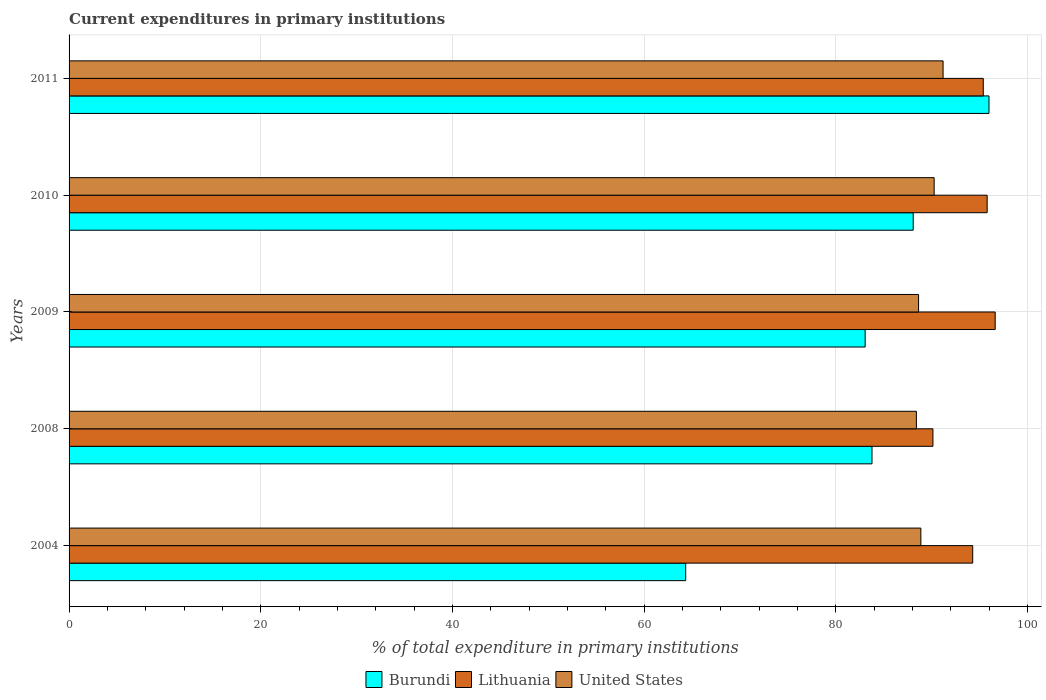How many different coloured bars are there?
Give a very brief answer. 3. How many groups of bars are there?
Your response must be concise. 5. How many bars are there on the 1st tick from the top?
Offer a very short reply. 3. How many bars are there on the 4th tick from the bottom?
Give a very brief answer. 3. In how many cases, is the number of bars for a given year not equal to the number of legend labels?
Offer a terse response. 0. What is the current expenditures in primary institutions in United States in 2010?
Give a very brief answer. 90.27. Across all years, what is the maximum current expenditures in primary institutions in Lithuania?
Your answer should be very brief. 96.64. Across all years, what is the minimum current expenditures in primary institutions in United States?
Give a very brief answer. 88.42. In which year was the current expenditures in primary institutions in Burundi maximum?
Your answer should be compact. 2011. What is the total current expenditures in primary institutions in United States in the graph?
Keep it short and to the point. 447.44. What is the difference between the current expenditures in primary institutions in Lithuania in 2009 and that in 2011?
Keep it short and to the point. 1.24. What is the difference between the current expenditures in primary institutions in United States in 2011 and the current expenditures in primary institutions in Burundi in 2008?
Offer a terse response. 7.42. What is the average current expenditures in primary institutions in Burundi per year?
Offer a terse response. 83.06. In the year 2008, what is the difference between the current expenditures in primary institutions in United States and current expenditures in primary institutions in Lithuania?
Your response must be concise. -1.73. In how many years, is the current expenditures in primary institutions in Burundi greater than 32 %?
Ensure brevity in your answer.  5. What is the ratio of the current expenditures in primary institutions in Lithuania in 2004 to that in 2009?
Provide a succinct answer. 0.98. What is the difference between the highest and the second highest current expenditures in primary institutions in Burundi?
Provide a short and direct response. 7.91. What is the difference between the highest and the lowest current expenditures in primary institutions in Burundi?
Offer a terse response. 31.65. What does the 2nd bar from the top in 2004 represents?
Provide a succinct answer. Lithuania. What does the 3rd bar from the bottom in 2004 represents?
Offer a very short reply. United States. Is it the case that in every year, the sum of the current expenditures in primary institutions in Burundi and current expenditures in primary institutions in Lithuania is greater than the current expenditures in primary institutions in United States?
Ensure brevity in your answer.  Yes. How many bars are there?
Provide a succinct answer. 15. Are all the bars in the graph horizontal?
Ensure brevity in your answer.  Yes. How many years are there in the graph?
Offer a terse response. 5. Does the graph contain grids?
Give a very brief answer. Yes. What is the title of the graph?
Provide a succinct answer. Current expenditures in primary institutions. What is the label or title of the X-axis?
Provide a succinct answer. % of total expenditure in primary institutions. What is the % of total expenditure in primary institutions of Burundi in 2004?
Your answer should be very brief. 64.35. What is the % of total expenditure in primary institutions of Lithuania in 2004?
Your response must be concise. 94.3. What is the % of total expenditure in primary institutions in United States in 2004?
Make the answer very short. 88.89. What is the % of total expenditure in primary institutions in Burundi in 2008?
Your answer should be compact. 83.79. What is the % of total expenditure in primary institutions in Lithuania in 2008?
Offer a terse response. 90.15. What is the % of total expenditure in primary institutions of United States in 2008?
Provide a succinct answer. 88.42. What is the % of total expenditure in primary institutions of Burundi in 2009?
Provide a short and direct response. 83.07. What is the % of total expenditure in primary institutions of Lithuania in 2009?
Make the answer very short. 96.64. What is the % of total expenditure in primary institutions in United States in 2009?
Make the answer very short. 88.65. What is the % of total expenditure in primary institutions in Burundi in 2010?
Provide a short and direct response. 88.09. What is the % of total expenditure in primary institutions of Lithuania in 2010?
Provide a short and direct response. 95.81. What is the % of total expenditure in primary institutions of United States in 2010?
Provide a short and direct response. 90.27. What is the % of total expenditure in primary institutions in Burundi in 2011?
Give a very brief answer. 96. What is the % of total expenditure in primary institutions in Lithuania in 2011?
Give a very brief answer. 95.4. What is the % of total expenditure in primary institutions in United States in 2011?
Offer a very short reply. 91.21. Across all years, what is the maximum % of total expenditure in primary institutions in Burundi?
Offer a terse response. 96. Across all years, what is the maximum % of total expenditure in primary institutions in Lithuania?
Make the answer very short. 96.64. Across all years, what is the maximum % of total expenditure in primary institutions in United States?
Offer a terse response. 91.21. Across all years, what is the minimum % of total expenditure in primary institutions of Burundi?
Ensure brevity in your answer.  64.35. Across all years, what is the minimum % of total expenditure in primary institutions in Lithuania?
Make the answer very short. 90.15. Across all years, what is the minimum % of total expenditure in primary institutions in United States?
Offer a very short reply. 88.42. What is the total % of total expenditure in primary institutions in Burundi in the graph?
Make the answer very short. 415.29. What is the total % of total expenditure in primary institutions of Lithuania in the graph?
Your answer should be compact. 472.29. What is the total % of total expenditure in primary institutions in United States in the graph?
Your answer should be compact. 447.44. What is the difference between the % of total expenditure in primary institutions of Burundi in 2004 and that in 2008?
Your response must be concise. -19.44. What is the difference between the % of total expenditure in primary institutions in Lithuania in 2004 and that in 2008?
Your answer should be compact. 4.15. What is the difference between the % of total expenditure in primary institutions of United States in 2004 and that in 2008?
Make the answer very short. 0.47. What is the difference between the % of total expenditure in primary institutions in Burundi in 2004 and that in 2009?
Your answer should be compact. -18.73. What is the difference between the % of total expenditure in primary institutions in Lithuania in 2004 and that in 2009?
Make the answer very short. -2.35. What is the difference between the % of total expenditure in primary institutions of United States in 2004 and that in 2009?
Offer a terse response. 0.24. What is the difference between the % of total expenditure in primary institutions in Burundi in 2004 and that in 2010?
Give a very brief answer. -23.74. What is the difference between the % of total expenditure in primary institutions in Lithuania in 2004 and that in 2010?
Your answer should be compact. -1.51. What is the difference between the % of total expenditure in primary institutions of United States in 2004 and that in 2010?
Your answer should be compact. -1.39. What is the difference between the % of total expenditure in primary institutions in Burundi in 2004 and that in 2011?
Your answer should be very brief. -31.65. What is the difference between the % of total expenditure in primary institutions of Lithuania in 2004 and that in 2011?
Give a very brief answer. -1.1. What is the difference between the % of total expenditure in primary institutions of United States in 2004 and that in 2011?
Offer a very short reply. -2.32. What is the difference between the % of total expenditure in primary institutions of Burundi in 2008 and that in 2009?
Make the answer very short. 0.71. What is the difference between the % of total expenditure in primary institutions of Lithuania in 2008 and that in 2009?
Keep it short and to the point. -6.5. What is the difference between the % of total expenditure in primary institutions of United States in 2008 and that in 2009?
Make the answer very short. -0.23. What is the difference between the % of total expenditure in primary institutions of Burundi in 2008 and that in 2010?
Provide a succinct answer. -4.3. What is the difference between the % of total expenditure in primary institutions of Lithuania in 2008 and that in 2010?
Your response must be concise. -5.66. What is the difference between the % of total expenditure in primary institutions in United States in 2008 and that in 2010?
Offer a very short reply. -1.85. What is the difference between the % of total expenditure in primary institutions of Burundi in 2008 and that in 2011?
Offer a very short reply. -12.21. What is the difference between the % of total expenditure in primary institutions of Lithuania in 2008 and that in 2011?
Provide a succinct answer. -5.25. What is the difference between the % of total expenditure in primary institutions in United States in 2008 and that in 2011?
Offer a very short reply. -2.78. What is the difference between the % of total expenditure in primary institutions in Burundi in 2009 and that in 2010?
Give a very brief answer. -5.01. What is the difference between the % of total expenditure in primary institutions of Lithuania in 2009 and that in 2010?
Keep it short and to the point. 0.84. What is the difference between the % of total expenditure in primary institutions in United States in 2009 and that in 2010?
Your response must be concise. -1.63. What is the difference between the % of total expenditure in primary institutions of Burundi in 2009 and that in 2011?
Ensure brevity in your answer.  -12.92. What is the difference between the % of total expenditure in primary institutions in Lithuania in 2009 and that in 2011?
Provide a succinct answer. 1.24. What is the difference between the % of total expenditure in primary institutions of United States in 2009 and that in 2011?
Offer a terse response. -2.56. What is the difference between the % of total expenditure in primary institutions in Burundi in 2010 and that in 2011?
Keep it short and to the point. -7.91. What is the difference between the % of total expenditure in primary institutions of Lithuania in 2010 and that in 2011?
Make the answer very short. 0.4. What is the difference between the % of total expenditure in primary institutions in United States in 2010 and that in 2011?
Ensure brevity in your answer.  -0.93. What is the difference between the % of total expenditure in primary institutions of Burundi in 2004 and the % of total expenditure in primary institutions of Lithuania in 2008?
Provide a short and direct response. -25.8. What is the difference between the % of total expenditure in primary institutions of Burundi in 2004 and the % of total expenditure in primary institutions of United States in 2008?
Offer a terse response. -24.07. What is the difference between the % of total expenditure in primary institutions of Lithuania in 2004 and the % of total expenditure in primary institutions of United States in 2008?
Your answer should be compact. 5.88. What is the difference between the % of total expenditure in primary institutions in Burundi in 2004 and the % of total expenditure in primary institutions in Lithuania in 2009?
Make the answer very short. -32.3. What is the difference between the % of total expenditure in primary institutions of Burundi in 2004 and the % of total expenditure in primary institutions of United States in 2009?
Your answer should be compact. -24.3. What is the difference between the % of total expenditure in primary institutions of Lithuania in 2004 and the % of total expenditure in primary institutions of United States in 2009?
Your answer should be very brief. 5.65. What is the difference between the % of total expenditure in primary institutions of Burundi in 2004 and the % of total expenditure in primary institutions of Lithuania in 2010?
Keep it short and to the point. -31.46. What is the difference between the % of total expenditure in primary institutions in Burundi in 2004 and the % of total expenditure in primary institutions in United States in 2010?
Ensure brevity in your answer.  -25.93. What is the difference between the % of total expenditure in primary institutions in Lithuania in 2004 and the % of total expenditure in primary institutions in United States in 2010?
Your answer should be very brief. 4.02. What is the difference between the % of total expenditure in primary institutions in Burundi in 2004 and the % of total expenditure in primary institutions in Lithuania in 2011?
Your answer should be compact. -31.05. What is the difference between the % of total expenditure in primary institutions in Burundi in 2004 and the % of total expenditure in primary institutions in United States in 2011?
Provide a succinct answer. -26.86. What is the difference between the % of total expenditure in primary institutions of Lithuania in 2004 and the % of total expenditure in primary institutions of United States in 2011?
Offer a terse response. 3.09. What is the difference between the % of total expenditure in primary institutions in Burundi in 2008 and the % of total expenditure in primary institutions in Lithuania in 2009?
Your answer should be compact. -12.85. What is the difference between the % of total expenditure in primary institutions in Burundi in 2008 and the % of total expenditure in primary institutions in United States in 2009?
Give a very brief answer. -4.86. What is the difference between the % of total expenditure in primary institutions in Lithuania in 2008 and the % of total expenditure in primary institutions in United States in 2009?
Your answer should be compact. 1.5. What is the difference between the % of total expenditure in primary institutions of Burundi in 2008 and the % of total expenditure in primary institutions of Lithuania in 2010?
Give a very brief answer. -12.02. What is the difference between the % of total expenditure in primary institutions of Burundi in 2008 and the % of total expenditure in primary institutions of United States in 2010?
Offer a terse response. -6.49. What is the difference between the % of total expenditure in primary institutions in Lithuania in 2008 and the % of total expenditure in primary institutions in United States in 2010?
Ensure brevity in your answer.  -0.13. What is the difference between the % of total expenditure in primary institutions of Burundi in 2008 and the % of total expenditure in primary institutions of Lithuania in 2011?
Provide a short and direct response. -11.61. What is the difference between the % of total expenditure in primary institutions in Burundi in 2008 and the % of total expenditure in primary institutions in United States in 2011?
Offer a very short reply. -7.42. What is the difference between the % of total expenditure in primary institutions of Lithuania in 2008 and the % of total expenditure in primary institutions of United States in 2011?
Offer a terse response. -1.06. What is the difference between the % of total expenditure in primary institutions of Burundi in 2009 and the % of total expenditure in primary institutions of Lithuania in 2010?
Keep it short and to the point. -12.73. What is the difference between the % of total expenditure in primary institutions of Burundi in 2009 and the % of total expenditure in primary institutions of United States in 2010?
Your answer should be very brief. -7.2. What is the difference between the % of total expenditure in primary institutions of Lithuania in 2009 and the % of total expenditure in primary institutions of United States in 2010?
Your answer should be compact. 6.37. What is the difference between the % of total expenditure in primary institutions of Burundi in 2009 and the % of total expenditure in primary institutions of Lithuania in 2011?
Your answer should be very brief. -12.33. What is the difference between the % of total expenditure in primary institutions of Burundi in 2009 and the % of total expenditure in primary institutions of United States in 2011?
Offer a terse response. -8.13. What is the difference between the % of total expenditure in primary institutions of Lithuania in 2009 and the % of total expenditure in primary institutions of United States in 2011?
Provide a short and direct response. 5.44. What is the difference between the % of total expenditure in primary institutions of Burundi in 2010 and the % of total expenditure in primary institutions of Lithuania in 2011?
Ensure brevity in your answer.  -7.31. What is the difference between the % of total expenditure in primary institutions of Burundi in 2010 and the % of total expenditure in primary institutions of United States in 2011?
Offer a very short reply. -3.12. What is the difference between the % of total expenditure in primary institutions in Lithuania in 2010 and the % of total expenditure in primary institutions in United States in 2011?
Provide a short and direct response. 4.6. What is the average % of total expenditure in primary institutions in Burundi per year?
Your answer should be compact. 83.06. What is the average % of total expenditure in primary institutions of Lithuania per year?
Your answer should be compact. 94.46. What is the average % of total expenditure in primary institutions of United States per year?
Offer a very short reply. 89.49. In the year 2004, what is the difference between the % of total expenditure in primary institutions of Burundi and % of total expenditure in primary institutions of Lithuania?
Provide a short and direct response. -29.95. In the year 2004, what is the difference between the % of total expenditure in primary institutions in Burundi and % of total expenditure in primary institutions in United States?
Give a very brief answer. -24.54. In the year 2004, what is the difference between the % of total expenditure in primary institutions in Lithuania and % of total expenditure in primary institutions in United States?
Keep it short and to the point. 5.41. In the year 2008, what is the difference between the % of total expenditure in primary institutions in Burundi and % of total expenditure in primary institutions in Lithuania?
Provide a short and direct response. -6.36. In the year 2008, what is the difference between the % of total expenditure in primary institutions in Burundi and % of total expenditure in primary institutions in United States?
Offer a very short reply. -4.63. In the year 2008, what is the difference between the % of total expenditure in primary institutions of Lithuania and % of total expenditure in primary institutions of United States?
Offer a very short reply. 1.73. In the year 2009, what is the difference between the % of total expenditure in primary institutions of Burundi and % of total expenditure in primary institutions of Lithuania?
Give a very brief answer. -13.57. In the year 2009, what is the difference between the % of total expenditure in primary institutions of Burundi and % of total expenditure in primary institutions of United States?
Provide a succinct answer. -5.57. In the year 2009, what is the difference between the % of total expenditure in primary institutions in Lithuania and % of total expenditure in primary institutions in United States?
Your answer should be very brief. 7.99. In the year 2010, what is the difference between the % of total expenditure in primary institutions of Burundi and % of total expenditure in primary institutions of Lithuania?
Keep it short and to the point. -7.72. In the year 2010, what is the difference between the % of total expenditure in primary institutions in Burundi and % of total expenditure in primary institutions in United States?
Provide a short and direct response. -2.19. In the year 2010, what is the difference between the % of total expenditure in primary institutions in Lithuania and % of total expenditure in primary institutions in United States?
Keep it short and to the point. 5.53. In the year 2011, what is the difference between the % of total expenditure in primary institutions of Burundi and % of total expenditure in primary institutions of Lithuania?
Your answer should be compact. 0.59. In the year 2011, what is the difference between the % of total expenditure in primary institutions in Burundi and % of total expenditure in primary institutions in United States?
Offer a very short reply. 4.79. In the year 2011, what is the difference between the % of total expenditure in primary institutions of Lithuania and % of total expenditure in primary institutions of United States?
Provide a succinct answer. 4.2. What is the ratio of the % of total expenditure in primary institutions of Burundi in 2004 to that in 2008?
Provide a succinct answer. 0.77. What is the ratio of the % of total expenditure in primary institutions in Lithuania in 2004 to that in 2008?
Make the answer very short. 1.05. What is the ratio of the % of total expenditure in primary institutions in Burundi in 2004 to that in 2009?
Keep it short and to the point. 0.77. What is the ratio of the % of total expenditure in primary institutions in Lithuania in 2004 to that in 2009?
Offer a terse response. 0.98. What is the ratio of the % of total expenditure in primary institutions of United States in 2004 to that in 2009?
Your answer should be very brief. 1. What is the ratio of the % of total expenditure in primary institutions of Burundi in 2004 to that in 2010?
Your response must be concise. 0.73. What is the ratio of the % of total expenditure in primary institutions of Lithuania in 2004 to that in 2010?
Offer a very short reply. 0.98. What is the ratio of the % of total expenditure in primary institutions in United States in 2004 to that in 2010?
Offer a terse response. 0.98. What is the ratio of the % of total expenditure in primary institutions of Burundi in 2004 to that in 2011?
Make the answer very short. 0.67. What is the ratio of the % of total expenditure in primary institutions in Lithuania in 2004 to that in 2011?
Your answer should be compact. 0.99. What is the ratio of the % of total expenditure in primary institutions in United States in 2004 to that in 2011?
Your response must be concise. 0.97. What is the ratio of the % of total expenditure in primary institutions of Burundi in 2008 to that in 2009?
Your response must be concise. 1.01. What is the ratio of the % of total expenditure in primary institutions in Lithuania in 2008 to that in 2009?
Offer a terse response. 0.93. What is the ratio of the % of total expenditure in primary institutions of Burundi in 2008 to that in 2010?
Ensure brevity in your answer.  0.95. What is the ratio of the % of total expenditure in primary institutions of Lithuania in 2008 to that in 2010?
Offer a very short reply. 0.94. What is the ratio of the % of total expenditure in primary institutions in United States in 2008 to that in 2010?
Your answer should be very brief. 0.98. What is the ratio of the % of total expenditure in primary institutions of Burundi in 2008 to that in 2011?
Offer a very short reply. 0.87. What is the ratio of the % of total expenditure in primary institutions of Lithuania in 2008 to that in 2011?
Ensure brevity in your answer.  0.94. What is the ratio of the % of total expenditure in primary institutions in United States in 2008 to that in 2011?
Keep it short and to the point. 0.97. What is the ratio of the % of total expenditure in primary institutions in Burundi in 2009 to that in 2010?
Give a very brief answer. 0.94. What is the ratio of the % of total expenditure in primary institutions of Lithuania in 2009 to that in 2010?
Your answer should be very brief. 1.01. What is the ratio of the % of total expenditure in primary institutions of United States in 2009 to that in 2010?
Ensure brevity in your answer.  0.98. What is the ratio of the % of total expenditure in primary institutions in Burundi in 2009 to that in 2011?
Give a very brief answer. 0.87. What is the ratio of the % of total expenditure in primary institutions of United States in 2009 to that in 2011?
Offer a very short reply. 0.97. What is the ratio of the % of total expenditure in primary institutions in Burundi in 2010 to that in 2011?
Make the answer very short. 0.92. What is the ratio of the % of total expenditure in primary institutions in United States in 2010 to that in 2011?
Provide a short and direct response. 0.99. What is the difference between the highest and the second highest % of total expenditure in primary institutions of Burundi?
Keep it short and to the point. 7.91. What is the difference between the highest and the second highest % of total expenditure in primary institutions in Lithuania?
Keep it short and to the point. 0.84. What is the difference between the highest and the second highest % of total expenditure in primary institutions of United States?
Keep it short and to the point. 0.93. What is the difference between the highest and the lowest % of total expenditure in primary institutions in Burundi?
Give a very brief answer. 31.65. What is the difference between the highest and the lowest % of total expenditure in primary institutions of Lithuania?
Your response must be concise. 6.5. What is the difference between the highest and the lowest % of total expenditure in primary institutions of United States?
Offer a very short reply. 2.78. 